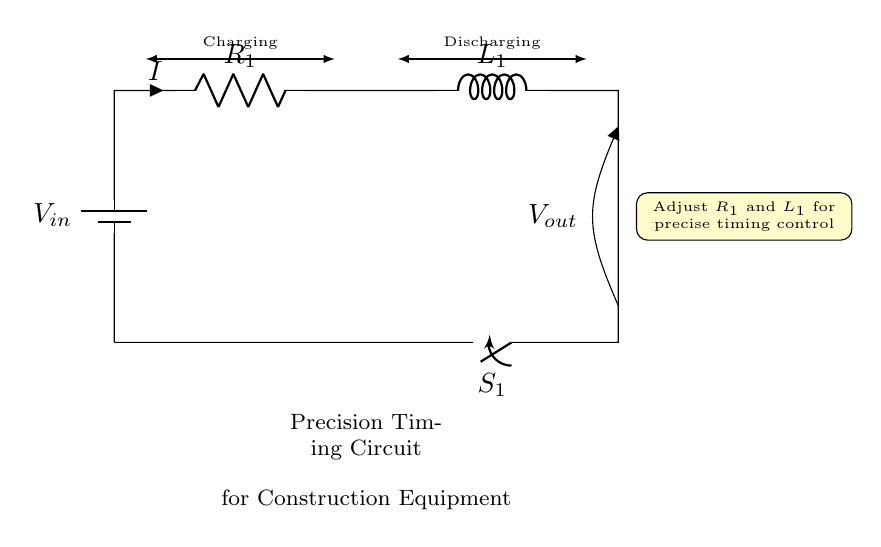What is the input voltage of this circuit? The input voltage is labeled as V_in at the top left of the circuit diagram, indicating the source potential.
Answer: V_in What type of switch is in this circuit? The circuit contains a switch labeled as S_1, which is responsible for controlling the current flow in the circuit.
Answer: Switch What does the inductor L_1 do during the discharging phase? During discharging, the inductor L_1 releases its stored energy, affecting the rate of current decay. This behavior is due to the inductor's property of opposing changes in current.
Answer: Releases energy How can timing be adjusted in this circuit? Timing can be adjusted by changing the values of R_1 and L_1, as indicated by the note in the circuit diagram that suggests adjusting these components for precise timing control.
Answer: Adjust R_1 and L_1 Which component determines the rate of charging? The resistor R_1 primarily determines the rate of charging, as it regulates the current flow into the inductor and affects the time constant of the circuit.
Answer: R_1 What happens when switch S_1 is closed? When switch S_1 is closed, the circuit completes, allowing current to flow through R_1 and L_1, initiating the charging phase of the timing circuit.
Answer: Current flows What is the output voltage labeled in the diagram? The output voltage is labeled as V_out, shown on the right side of the inductor, indicating where the output voltage is measured from the circuit.
Answer: V_out 